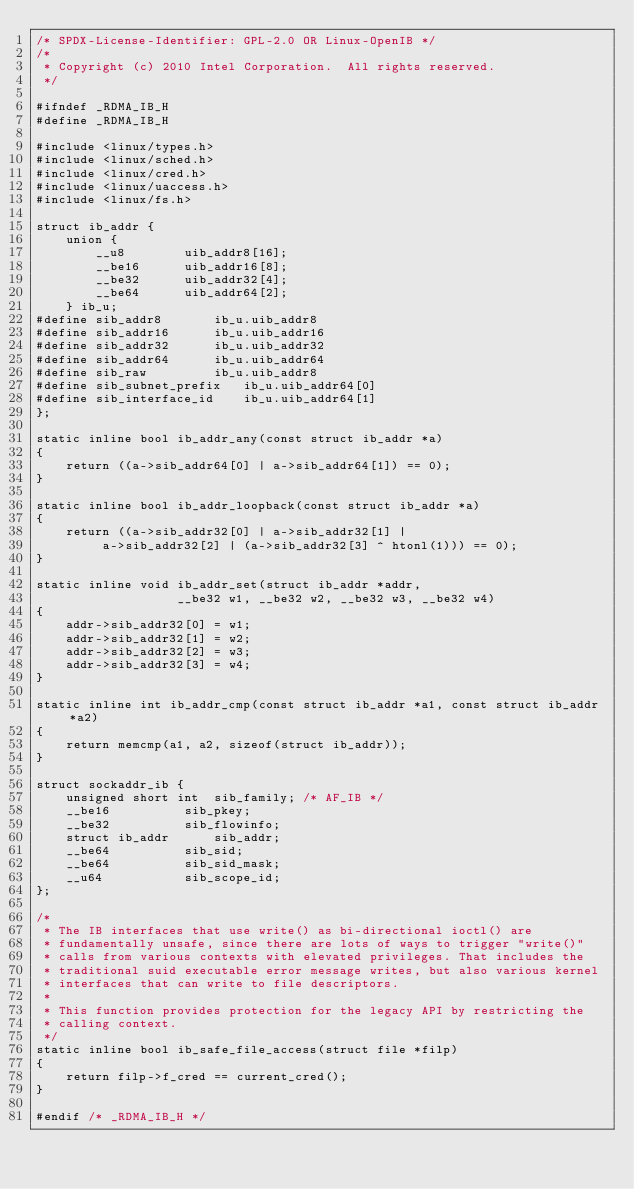Convert code to text. <code><loc_0><loc_0><loc_500><loc_500><_C_>/* SPDX-License-Identifier: GPL-2.0 OR Linux-OpenIB */
/*
 * Copyright (c) 2010 Intel Corporation.  All rights reserved.
 */

#ifndef _RDMA_IB_H
#define _RDMA_IB_H

#include <linux/types.h>
#include <linux/sched.h>
#include <linux/cred.h>
#include <linux/uaccess.h>
#include <linux/fs.h>

struct ib_addr {
	union {
		__u8		uib_addr8[16];
		__be16		uib_addr16[8];
		__be32		uib_addr32[4];
		__be64		uib_addr64[2];
	} ib_u;
#define sib_addr8		ib_u.uib_addr8
#define sib_addr16		ib_u.uib_addr16
#define sib_addr32		ib_u.uib_addr32
#define sib_addr64		ib_u.uib_addr64
#define sib_raw			ib_u.uib_addr8
#define sib_subnet_prefix	ib_u.uib_addr64[0]
#define sib_interface_id	ib_u.uib_addr64[1]
};

static inline bool ib_addr_any(const struct ib_addr *a)
{
	return ((a->sib_addr64[0] | a->sib_addr64[1]) == 0);
}

static inline bool ib_addr_loopback(const struct ib_addr *a)
{
	return ((a->sib_addr32[0] | a->sib_addr32[1] |
		 a->sib_addr32[2] | (a->sib_addr32[3] ^ htonl(1))) == 0);
}

static inline void ib_addr_set(struct ib_addr *addr,
			       __be32 w1, __be32 w2, __be32 w3, __be32 w4)
{
	addr->sib_addr32[0] = w1;
	addr->sib_addr32[1] = w2;
	addr->sib_addr32[2] = w3;
	addr->sib_addr32[3] = w4;
}

static inline int ib_addr_cmp(const struct ib_addr *a1, const struct ib_addr *a2)
{
	return memcmp(a1, a2, sizeof(struct ib_addr));
}

struct sockaddr_ib {
	unsigned short int	sib_family;	/* AF_IB */
	__be16			sib_pkey;
	__be32			sib_flowinfo;
	struct ib_addr		sib_addr;
	__be64			sib_sid;
	__be64			sib_sid_mask;
	__u64			sib_scope_id;
};

/*
 * The IB interfaces that use write() as bi-directional ioctl() are
 * fundamentally unsafe, since there are lots of ways to trigger "write()"
 * calls from various contexts with elevated privileges. That includes the
 * traditional suid executable error message writes, but also various kernel
 * interfaces that can write to file descriptors.
 *
 * This function provides protection for the legacy API by restricting the
 * calling context.
 */
static inline bool ib_safe_file_access(struct file *filp)
{
	return filp->f_cred == current_cred();
}

#endif /* _RDMA_IB_H */
</code> 